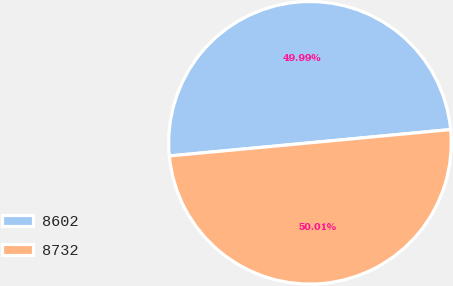Convert chart to OTSL. <chart><loc_0><loc_0><loc_500><loc_500><pie_chart><fcel>8602<fcel>8732<nl><fcel>49.99%<fcel>50.01%<nl></chart> 